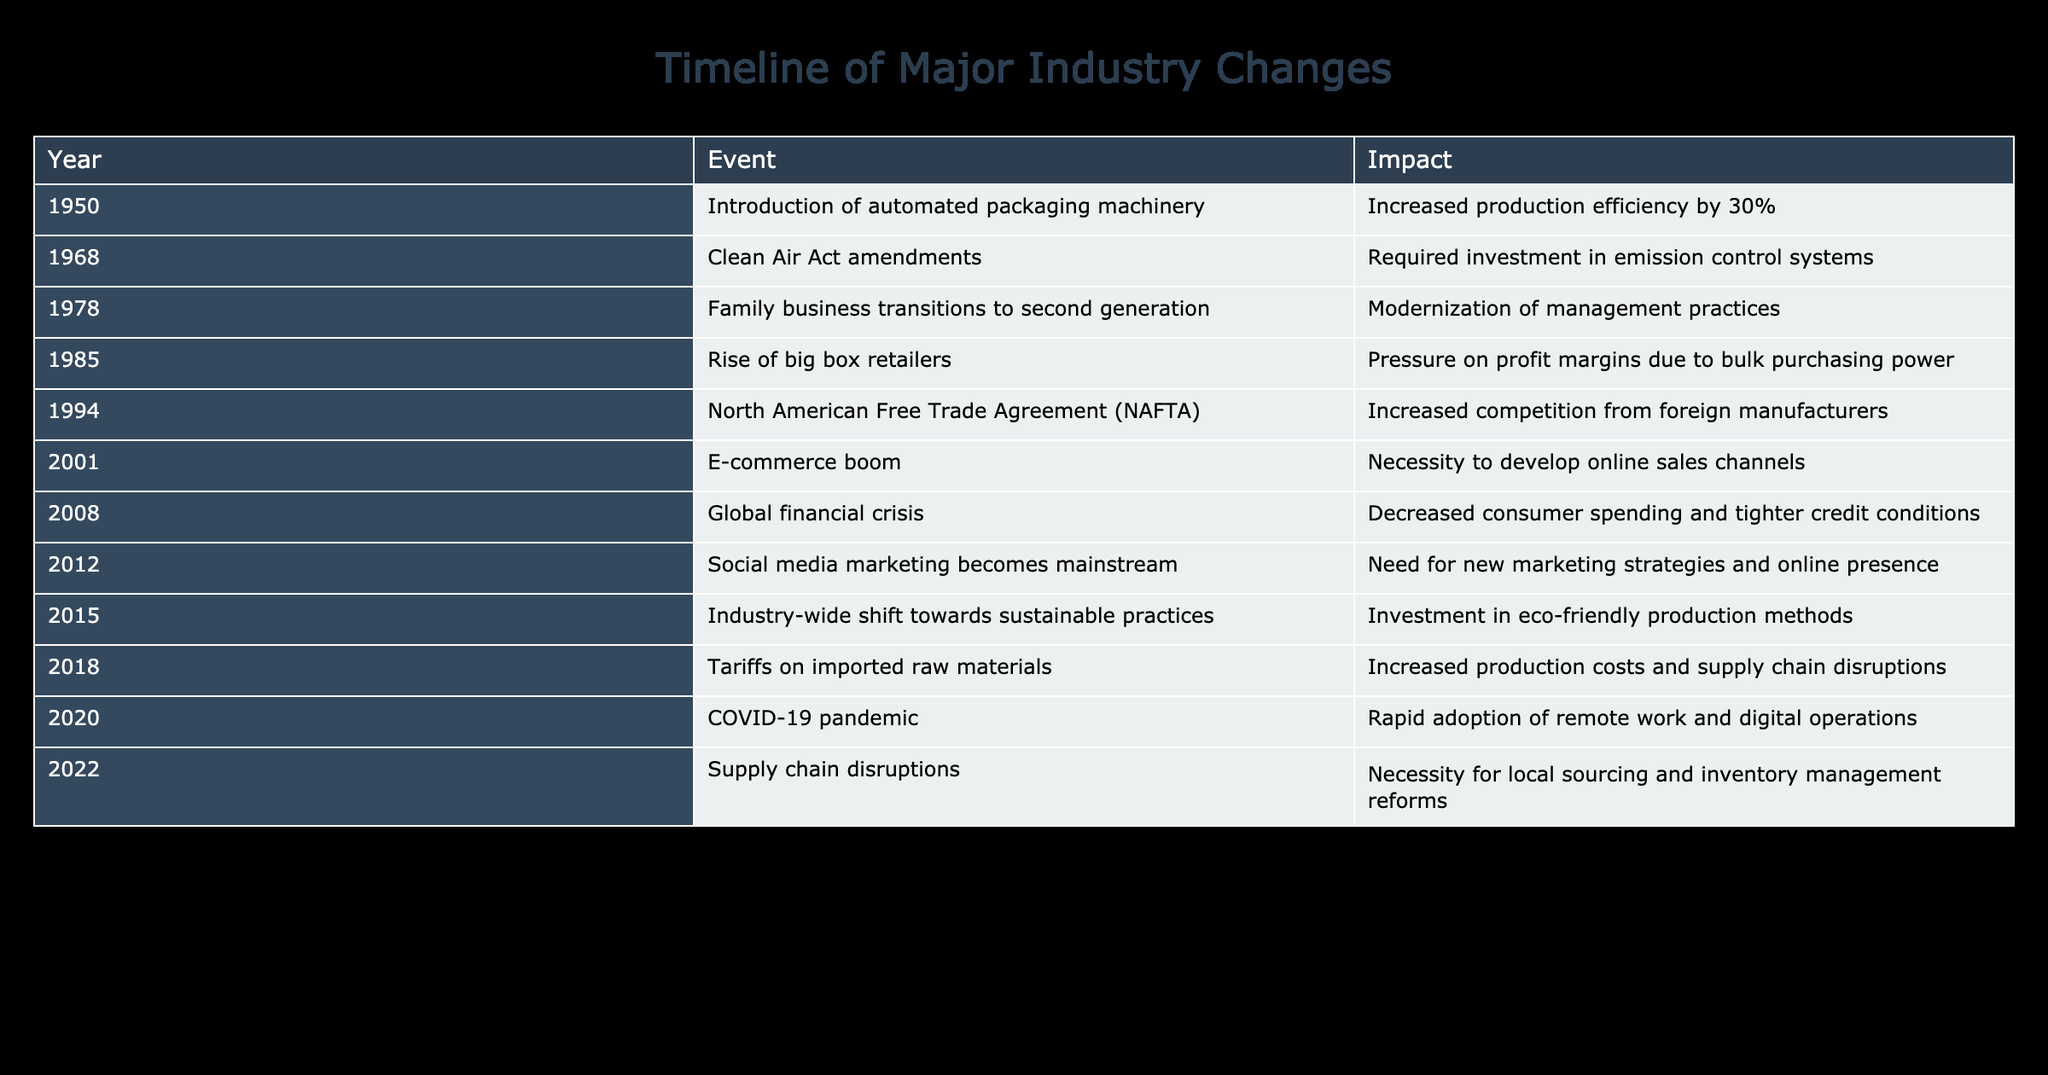What year was the introduction of automated packaging machinery? The table indicates that the event of automated packaging machinery was introduced in the year 1950.
Answer: 1950 What was the impact of the Clean Air Act amendments? According to the table, the Clean Air Act amendments required investment in emission control systems, making it a significant regulatory change for businesses.
Answer: Required investment in emission control systems Was there an increase or decrease in production efficiency due to the introduction of automated packaging machinery? The table specifies that the introduction of automated packaging machinery increased production efficiency by 30%, indicating a positive impact.
Answer: Increase How many years passed between the transition to the second generation of the family business and the introduction of e-commerce? From the table, the transition to the second generation occurred in 1978, and the e-commerce boom happened in 2001. The difference in years is 2001 - 1978 = 23 years.
Answer: 23 years Which events in the timeline could have resulted in increased production costs? Reviewing the table, two events impacted production costs: the tariffs on imported raw materials in 2018, which increased costs, and the global financial crisis in 2008, which likely caused decreased spending but may have influenced costs through tighter credit conditions. Both events should be considered when evaluating new cost pressures.
Answer: Tariffs on imported raw materials (2018) and global financial crisis (2008) How does the impact of the COVID-19 pandemic compare with other events in terms of necessity for change in operations? The table reveals that the impact of the COVID-19 pandemic led to the rapid adoption of remote work and digital operations, which is quite significant compared to other events. Generally, many of the other changes required adaptation, but none had such a wide-reaching effect on operational structure in a short time. Hence, it can be regarded as one of the most critical shifts.
Answer: Significant and critical shift In which year did the industry-wide shift towards sustainable practices occur? The table clearly states that the industry-wide shift towards sustainable practices took place in 2015.
Answer: 2015 Was the introduction of social media marketing a necessity or a choice for businesses based on the timeline? The table indicates that social media marketing became mainstream in 2012, implying that businesses needed to adopt new marketing strategies and improve their online presence. Therefore, it can be inferred that it was more of a necessity than a choice.
Answer: Necessity What were the combined impacts of the rise of big box retailers and the North American Free Trade Agreement? The rise of big box retailers was associated with pressure on profit margins due to bulk purchasing power, while NAFTA led to increased competition from foreign manufacturers. Together, these events likely compounded the competitive pressure on local businesses, leading to tighter profit margins and the need to innovate or cut costs.
Answer: Combined pressure on local businesses What percentage increase in efficiency did automated packaging machinery provide compared to the impact recorded in sustainable practices? The efficiency increase from automated packaging machinery was 30%, and the impact from the shift toward sustainable practices required investment but does not quantify efficiency changes directly. This makes it challenging to compare percentages effectively; therefore, it yields little specific quantitative insight. However, automated efficiency was explicitly stated.
Answer: 30% efficiency increase instead of a percentage from sustainability impact 